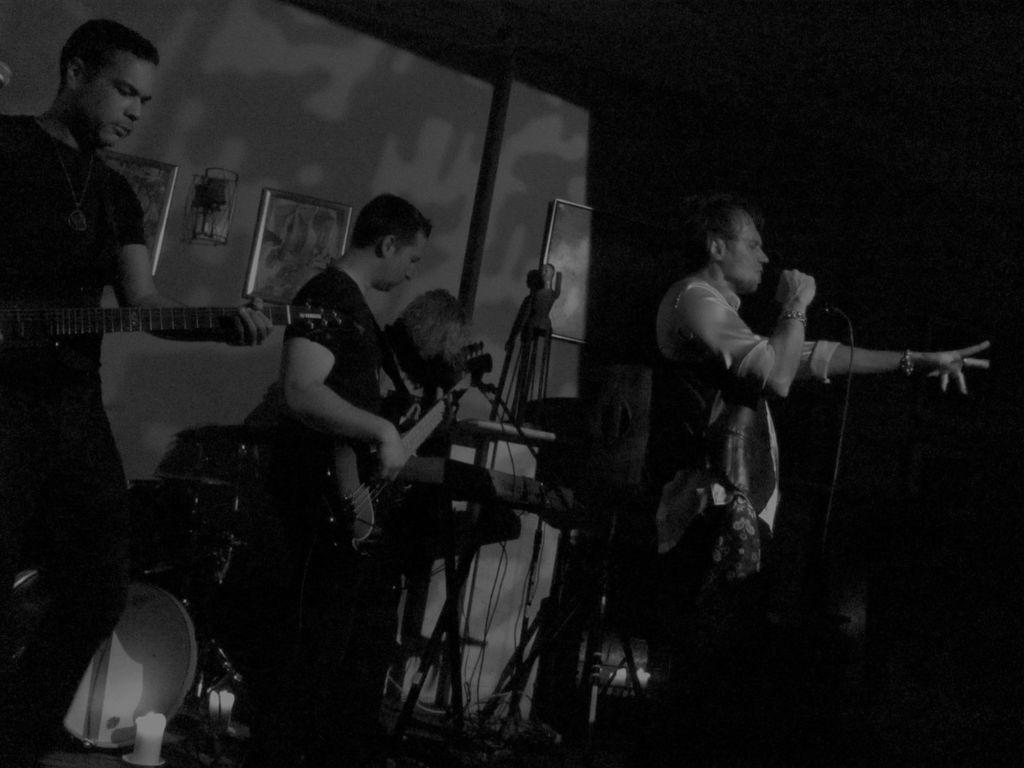Describe this image in one or two sentences. This is completely a black and white picture. Here we can see persons playing guitars and drums. This man is holding a mike in his hand and singing. 